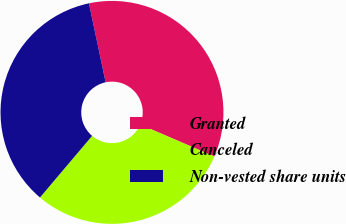<chart> <loc_0><loc_0><loc_500><loc_500><pie_chart><fcel>Granted<fcel>Canceled<fcel>Non-vested share units<nl><fcel>34.79%<fcel>29.7%<fcel>35.51%<nl></chart> 